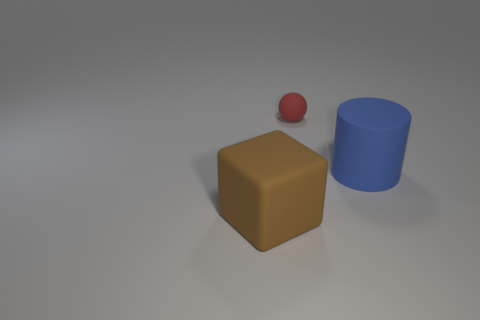Add 1 large gray cylinders. How many objects exist? 4 Add 1 small spheres. How many small spheres are left? 2 Add 3 big brown rubber cubes. How many big brown rubber cubes exist? 4 Subtract 0 brown cylinders. How many objects are left? 3 Subtract all cubes. How many objects are left? 2 Subtract all tiny red balls. Subtract all large cyan spheres. How many objects are left? 2 